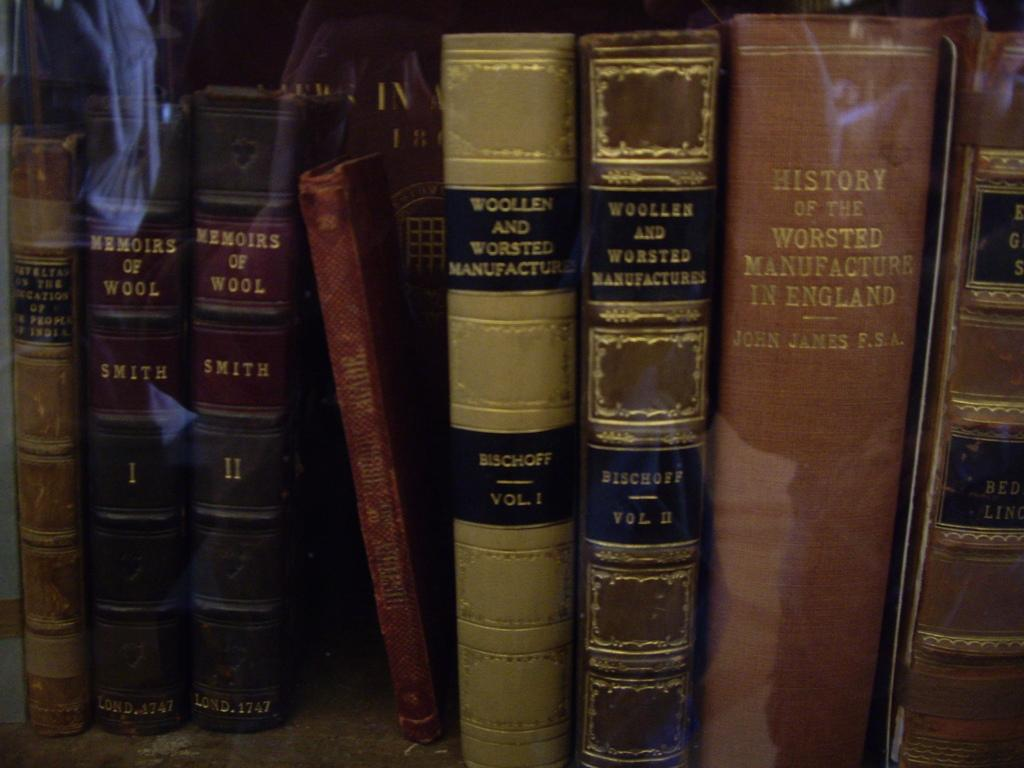What is the main subject in the image? There is a rack of books in the image. Are there any icicles hanging from the books in the image? There are no icicles present in the image; it features a rack of books. Can you tell me how many airports are visible in the image? There are no airports present in the image, as it only features a rack of books. 